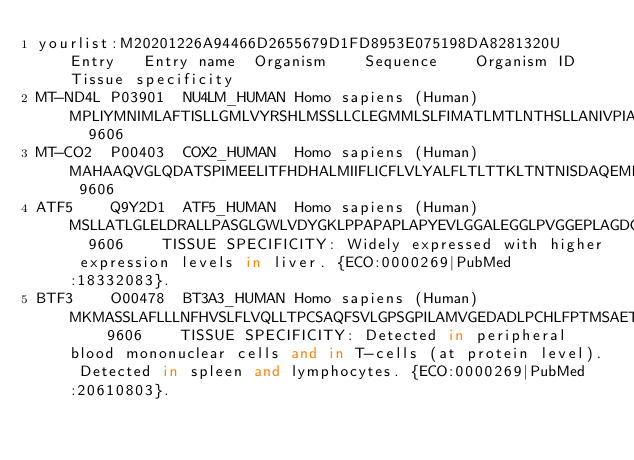<code> <loc_0><loc_0><loc_500><loc_500><_SQL_>yourlist:M20201226A94466D2655679D1FD8953E075198DA8281320U	Entry	Entry name	Organism	Sequence	Organism ID	Tissue specificity
MT-ND4L	P03901	NU4LM_HUMAN	Homo sapiens (Human)	MPLIYMNIMLAFTISLLGMLVYRSHLMSSLLCLEGMMLSLFIMATLMTLNTHSLLANIVPIAMLVFAACEAAVGLALLVSISNTYGLDYVHNLNLLQC	9606	
MT-CO2	P00403	COX2_HUMAN	Homo sapiens (Human)	MAHAAQVGLQDATSPIMEELITFHDHALMIIFLICFLVLYALFLTLTTKLTNTNISDAQEMETVWTILPAIILVLIALPSLRILYMTDEVNDPSLTIKSIGHQWYWTYEYTDYGGLIFNSYMLPPLFLEPGDLRLLDVDNRVVLPIEAPIRMMITSQDVLHSWAVPTLGLKTDAIPGRLNQTTFTATRPGVYYGQCSEICGANHSFMPIVLELIPLKIFEMGPVFTL	9606	
ATF5	Q9Y2D1	ATF5_HUMAN	Homo sapiens (Human)	MSLLATLGLELDRALLPASGLGWLVDYGKLPPAPAPLAPYEVLGGALEGGLPVGGEPLAGDGFSDWMTERVDFTALLPLEPPLPPGTLPQPSPTPPDLEAMASLLKKELEQMEDFFLDAPPLPPPSPPPLPPPPLPPAPSLPLSLPSFDLPQPPVLDTLDLLAIYCRNEAGQEEVGMPPLPPPQQPPPPSPPQPSRLAPYPHPATTRGDRKQKKRDQNKSAALRYRQRKRAEGEALEGECQGLEARNRELKERAESVEREIQYVKDLLIEVYKARSQRTRSC	9606	TISSUE SPECIFICITY: Widely expressed with higher expression levels in liver. {ECO:0000269|PubMed:18332083}.
BTF3	O00478	BT3A3_HUMAN	Homo sapiens (Human)	MKMASSLAFLLLNFHVSLFLVQLLTPCSAQFSVLGPSGPILAMVGEDADLPCHLFPTMSAETMELRWVSSSLRQVVNVYADGKEVEDRQSAPYRGRTSILRDGITAGKAALRIHNVTASDSGKYLCYFQDGDFYEKALVELKVAALGSDLHIEVKGYEDGGIHLECRSTGWYPQPQIKWSDTKGENIPAVEAPVVADGVGLYAVAASVIMRGSSGGGVSCIIRNSLLGLEKTASISIADPFFRSAQPWIAALAGTLPISLLLLAGASYFLWRQQKEKIALSRETEREREMKEMGYAATEQEISLREKLQEELKWRKIQYMARGEKSLAYHEWKMALFKPADVILDPDTANAILLVSEDQRSVQRAEEPRDLPDNPERFEWRYCVLGCENFTSGRHYWEVEVGDRKEWHIGVCSKNVERKKGWVKMTPENGYWTMGLTDGNKYRALTEPRTNLKLPEPPRKVGIFLDYETGEISFYNATDGSHIYTFPHASFSEPLYPVFRILTLEPTALTICPIPKEVESSPDPDLVPDHSLETPLTPGLANESGEPQAEVTSLLLPAHPGAEVSPSATTNQNHKLQARTEALY	9606	TISSUE SPECIFICITY: Detected in peripheral blood mononuclear cells and in T-cells (at protein level). Detected in spleen and lymphocytes. {ECO:0000269|PubMed:20610803}.</code> 